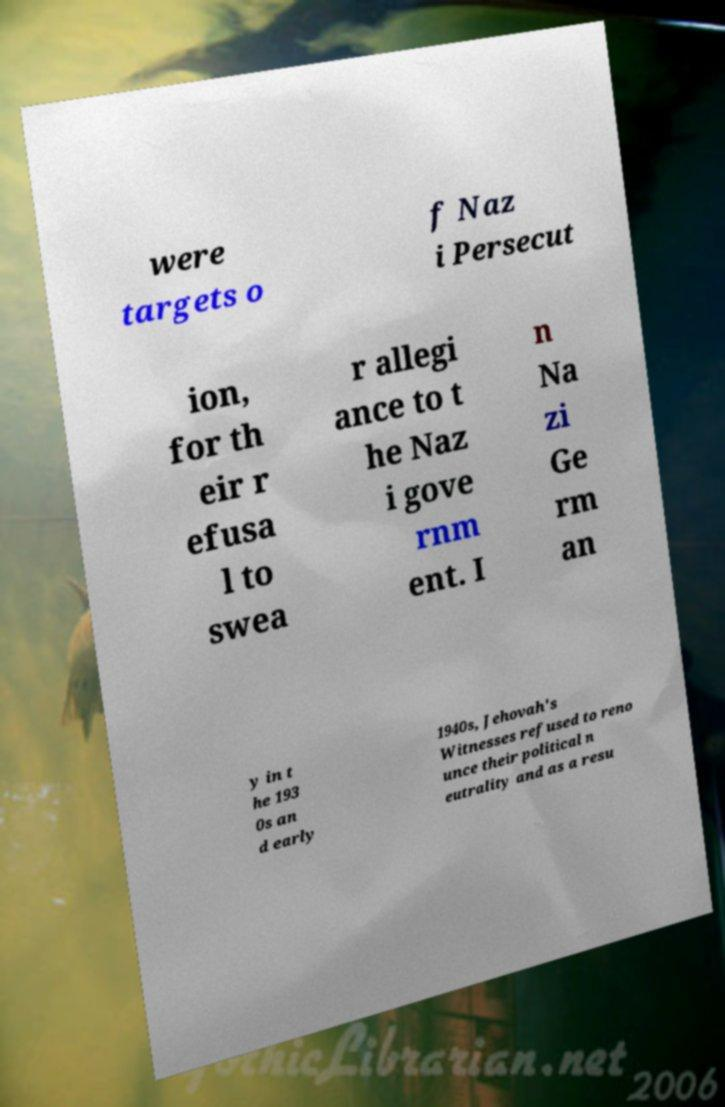For documentation purposes, I need the text within this image transcribed. Could you provide that? were targets o f Naz i Persecut ion, for th eir r efusa l to swea r allegi ance to t he Naz i gove rnm ent. I n Na zi Ge rm an y in t he 193 0s an d early 1940s, Jehovah's Witnesses refused to reno unce their political n eutrality and as a resu 